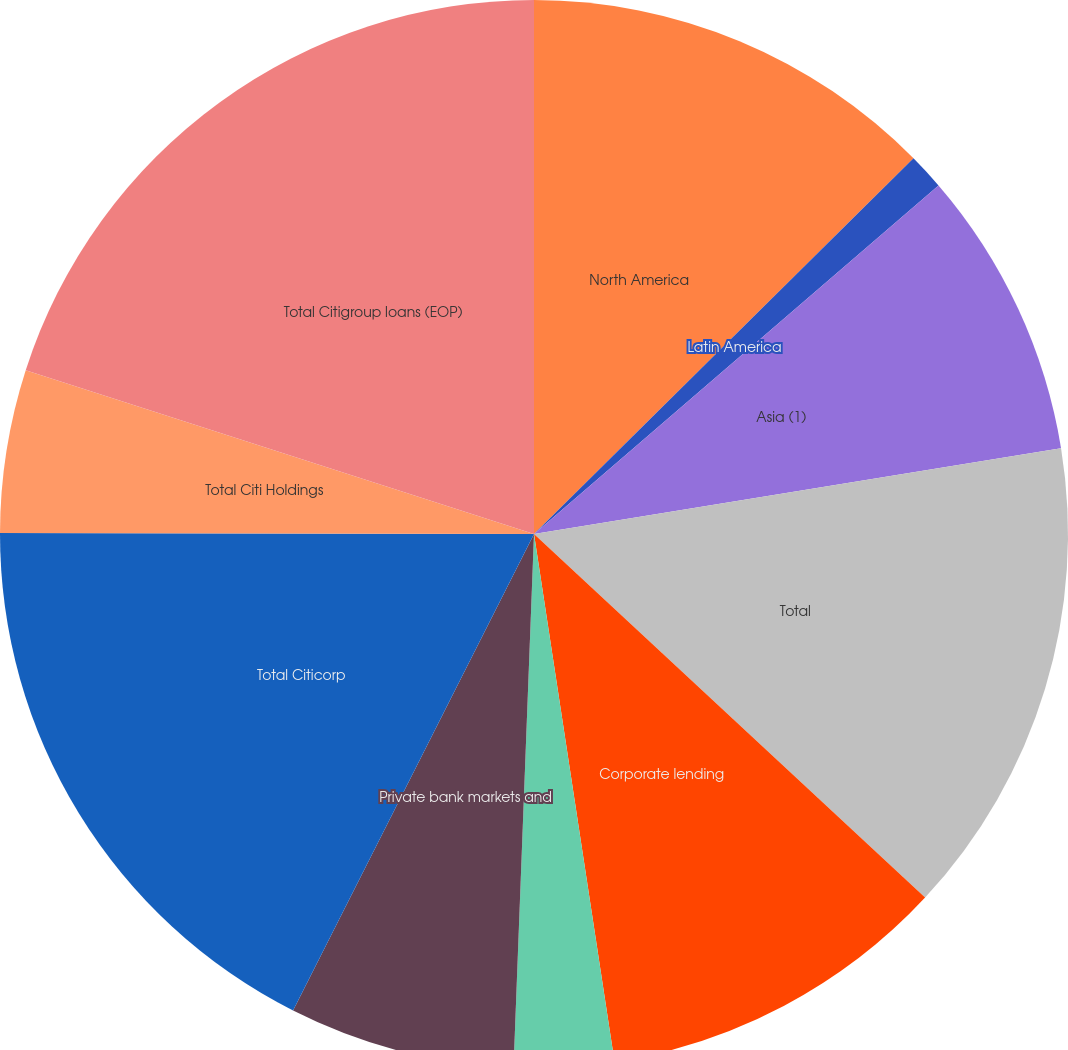Convert chart. <chart><loc_0><loc_0><loc_500><loc_500><pie_chart><fcel>North America<fcel>Latin America<fcel>Asia (1)<fcel>Total<fcel>Corporate lending<fcel>Treasury and trade solutions<fcel>Private bank markets and<fcel>Total Citicorp<fcel>Total Citi Holdings<fcel>Total Citigroup loans (EOP)<nl><fcel>12.58%<fcel>1.1%<fcel>8.75%<fcel>14.49%<fcel>10.67%<fcel>3.02%<fcel>6.84%<fcel>17.58%<fcel>4.93%<fcel>20.04%<nl></chart> 